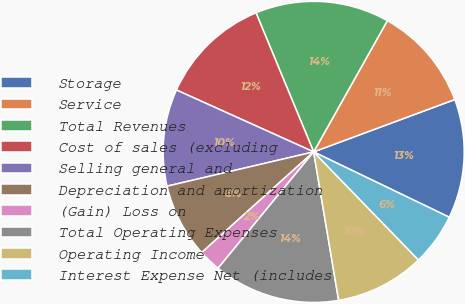Convert chart to OTSL. <chart><loc_0><loc_0><loc_500><loc_500><pie_chart><fcel>Storage<fcel>Service<fcel>Total Revenues<fcel>Cost of sales (excluding<fcel>Selling general and<fcel>Depreciation and amortization<fcel>(Gain) Loss on<fcel>Total Operating Expenses<fcel>Operating Income<fcel>Interest Expense Net (includes<nl><fcel>12.8%<fcel>11.2%<fcel>14.4%<fcel>12.0%<fcel>10.4%<fcel>8.0%<fcel>2.4%<fcel>13.6%<fcel>9.6%<fcel>5.6%<nl></chart> 